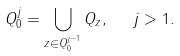<formula> <loc_0><loc_0><loc_500><loc_500>Q ^ { j } _ { 0 } = \bigcup _ { z \in Q ^ { j - 1 } _ { 0 } } Q _ { z } , \ \ j > 1 .</formula> 